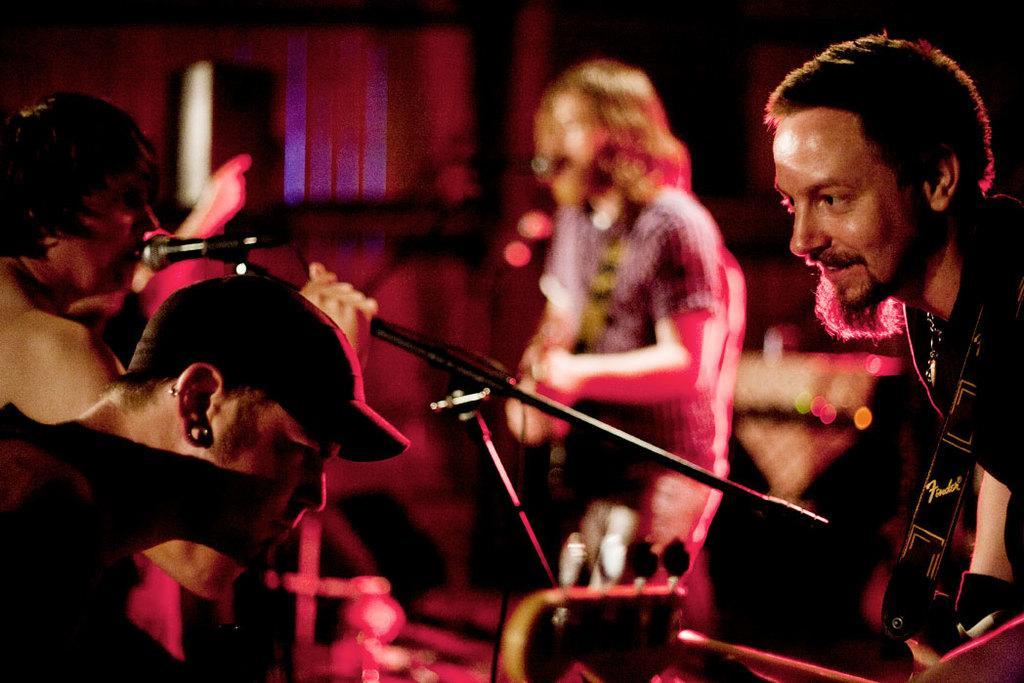In one or two sentences, can you explain what this image depicts? In this image I can see a person wearing a hat and another person is holding a musical instrument, a microphone and a woman holding a microphone. In the background I can see a person standing and holding a musical instrument, a microphone and few other objects. 